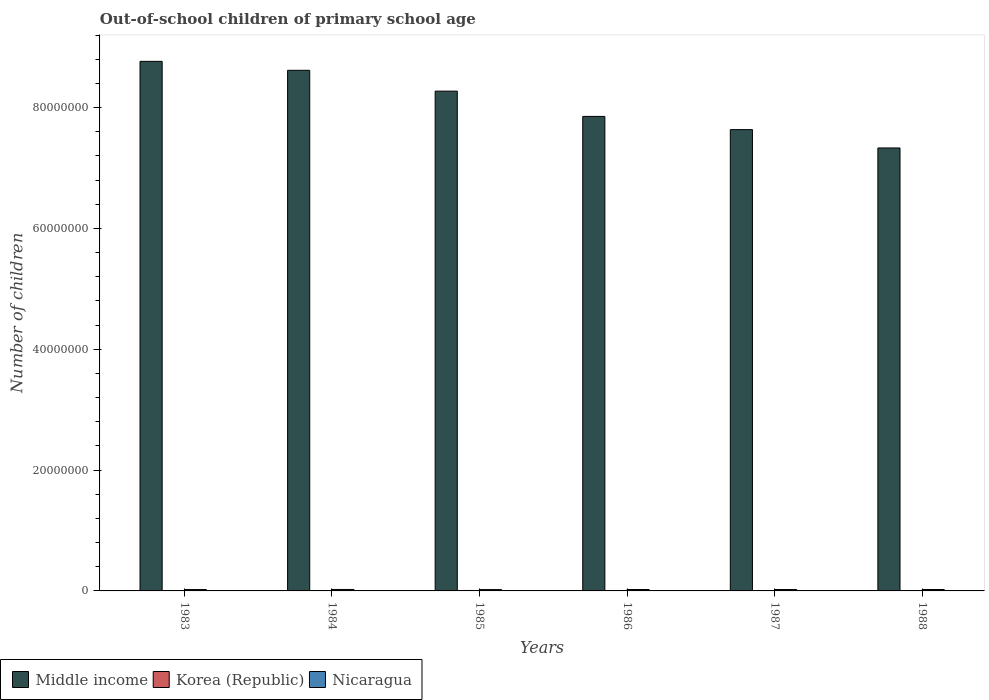How many different coloured bars are there?
Give a very brief answer. 3. How many groups of bars are there?
Offer a very short reply. 6. How many bars are there on the 2nd tick from the right?
Give a very brief answer. 3. What is the label of the 6th group of bars from the left?
Give a very brief answer. 1988. In how many cases, is the number of bars for a given year not equal to the number of legend labels?
Ensure brevity in your answer.  0. What is the number of out-of-school children in Korea (Republic) in 1987?
Give a very brief answer. 1.84e+04. Across all years, what is the maximum number of out-of-school children in Korea (Republic)?
Offer a terse response. 7.36e+04. Across all years, what is the minimum number of out-of-school children in Middle income?
Provide a short and direct response. 7.33e+07. In which year was the number of out-of-school children in Middle income minimum?
Ensure brevity in your answer.  1988. What is the total number of out-of-school children in Korea (Republic) in the graph?
Provide a succinct answer. 2.33e+05. What is the difference between the number of out-of-school children in Nicaragua in 1983 and that in 1984?
Make the answer very short. -1.61e+04. What is the difference between the number of out-of-school children in Korea (Republic) in 1985 and the number of out-of-school children in Nicaragua in 1984?
Your answer should be compact. -1.68e+05. What is the average number of out-of-school children in Nicaragua per year?
Ensure brevity in your answer.  2.31e+05. In the year 1983, what is the difference between the number of out-of-school children in Middle income and number of out-of-school children in Nicaragua?
Ensure brevity in your answer.  8.74e+07. What is the ratio of the number of out-of-school children in Middle income in 1983 to that in 1985?
Offer a very short reply. 1.06. What is the difference between the highest and the second highest number of out-of-school children in Middle income?
Your response must be concise. 1.48e+06. What is the difference between the highest and the lowest number of out-of-school children in Middle income?
Provide a short and direct response. 1.43e+07. In how many years, is the number of out-of-school children in Korea (Republic) greater than the average number of out-of-school children in Korea (Republic) taken over all years?
Keep it short and to the point. 3. What does the 3rd bar from the left in 1988 represents?
Ensure brevity in your answer.  Nicaragua. Is it the case that in every year, the sum of the number of out-of-school children in Korea (Republic) and number of out-of-school children in Nicaragua is greater than the number of out-of-school children in Middle income?
Make the answer very short. No. Are all the bars in the graph horizontal?
Keep it short and to the point. No. What is the difference between two consecutive major ticks on the Y-axis?
Provide a succinct answer. 2.00e+07. Does the graph contain any zero values?
Give a very brief answer. No. Does the graph contain grids?
Offer a very short reply. No. Where does the legend appear in the graph?
Ensure brevity in your answer.  Bottom left. How many legend labels are there?
Ensure brevity in your answer.  3. How are the legend labels stacked?
Make the answer very short. Horizontal. What is the title of the graph?
Offer a very short reply. Out-of-school children of primary school age. What is the label or title of the Y-axis?
Offer a terse response. Number of children. What is the Number of children in Middle income in 1983?
Offer a terse response. 8.77e+07. What is the Number of children of Korea (Republic) in 1983?
Ensure brevity in your answer.  9682. What is the Number of children of Nicaragua in 1983?
Provide a succinct answer. 2.25e+05. What is the Number of children in Middle income in 1984?
Keep it short and to the point. 8.62e+07. What is the Number of children in Korea (Republic) in 1984?
Keep it short and to the point. 4.08e+04. What is the Number of children of Nicaragua in 1984?
Your response must be concise. 2.41e+05. What is the Number of children in Middle income in 1985?
Ensure brevity in your answer.  8.27e+07. What is the Number of children of Korea (Republic) in 1985?
Provide a succinct answer. 7.36e+04. What is the Number of children in Nicaragua in 1985?
Give a very brief answer. 2.21e+05. What is the Number of children of Middle income in 1986?
Ensure brevity in your answer.  7.85e+07. What is the Number of children in Korea (Republic) in 1986?
Make the answer very short. 7.14e+04. What is the Number of children of Nicaragua in 1986?
Make the answer very short. 2.34e+05. What is the Number of children of Middle income in 1987?
Provide a succinct answer. 7.64e+07. What is the Number of children of Korea (Republic) in 1987?
Offer a terse response. 1.84e+04. What is the Number of children in Nicaragua in 1987?
Provide a succinct answer. 2.29e+05. What is the Number of children in Middle income in 1988?
Provide a short and direct response. 7.33e+07. What is the Number of children in Korea (Republic) in 1988?
Offer a very short reply. 1.92e+04. What is the Number of children of Nicaragua in 1988?
Provide a succinct answer. 2.34e+05. Across all years, what is the maximum Number of children of Middle income?
Offer a terse response. 8.77e+07. Across all years, what is the maximum Number of children in Korea (Republic)?
Make the answer very short. 7.36e+04. Across all years, what is the maximum Number of children of Nicaragua?
Keep it short and to the point. 2.41e+05. Across all years, what is the minimum Number of children in Middle income?
Your answer should be compact. 7.33e+07. Across all years, what is the minimum Number of children of Korea (Republic)?
Offer a very short reply. 9682. Across all years, what is the minimum Number of children of Nicaragua?
Ensure brevity in your answer.  2.21e+05. What is the total Number of children of Middle income in the graph?
Your answer should be very brief. 4.85e+08. What is the total Number of children in Korea (Republic) in the graph?
Your answer should be compact. 2.33e+05. What is the total Number of children in Nicaragua in the graph?
Your response must be concise. 1.39e+06. What is the difference between the Number of children in Middle income in 1983 and that in 1984?
Keep it short and to the point. 1.48e+06. What is the difference between the Number of children of Korea (Republic) in 1983 and that in 1984?
Make the answer very short. -3.11e+04. What is the difference between the Number of children of Nicaragua in 1983 and that in 1984?
Keep it short and to the point. -1.61e+04. What is the difference between the Number of children of Middle income in 1983 and that in 1985?
Provide a succinct answer. 4.93e+06. What is the difference between the Number of children in Korea (Republic) in 1983 and that in 1985?
Offer a very short reply. -6.39e+04. What is the difference between the Number of children of Nicaragua in 1983 and that in 1985?
Your response must be concise. 3647. What is the difference between the Number of children in Middle income in 1983 and that in 1986?
Your answer should be very brief. 9.11e+06. What is the difference between the Number of children in Korea (Republic) in 1983 and that in 1986?
Make the answer very short. -6.17e+04. What is the difference between the Number of children in Nicaragua in 1983 and that in 1986?
Provide a succinct answer. -9017. What is the difference between the Number of children in Middle income in 1983 and that in 1987?
Offer a very short reply. 1.13e+07. What is the difference between the Number of children in Korea (Republic) in 1983 and that in 1987?
Keep it short and to the point. -8751. What is the difference between the Number of children of Nicaragua in 1983 and that in 1987?
Provide a succinct answer. -4156. What is the difference between the Number of children of Middle income in 1983 and that in 1988?
Your response must be concise. 1.43e+07. What is the difference between the Number of children of Korea (Republic) in 1983 and that in 1988?
Your answer should be compact. -9494. What is the difference between the Number of children in Nicaragua in 1983 and that in 1988?
Keep it short and to the point. -8803. What is the difference between the Number of children in Middle income in 1984 and that in 1985?
Make the answer very short. 3.45e+06. What is the difference between the Number of children of Korea (Republic) in 1984 and that in 1985?
Ensure brevity in your answer.  -3.28e+04. What is the difference between the Number of children in Nicaragua in 1984 and that in 1985?
Make the answer very short. 1.98e+04. What is the difference between the Number of children of Middle income in 1984 and that in 1986?
Provide a succinct answer. 7.63e+06. What is the difference between the Number of children of Korea (Republic) in 1984 and that in 1986?
Offer a terse response. -3.06e+04. What is the difference between the Number of children of Nicaragua in 1984 and that in 1986?
Offer a very short reply. 7090. What is the difference between the Number of children in Middle income in 1984 and that in 1987?
Offer a very short reply. 9.82e+06. What is the difference between the Number of children in Korea (Republic) in 1984 and that in 1987?
Your answer should be compact. 2.23e+04. What is the difference between the Number of children in Nicaragua in 1984 and that in 1987?
Provide a short and direct response. 1.20e+04. What is the difference between the Number of children of Middle income in 1984 and that in 1988?
Offer a very short reply. 1.29e+07. What is the difference between the Number of children in Korea (Republic) in 1984 and that in 1988?
Your answer should be compact. 2.16e+04. What is the difference between the Number of children in Nicaragua in 1984 and that in 1988?
Provide a short and direct response. 7304. What is the difference between the Number of children of Middle income in 1985 and that in 1986?
Your answer should be very brief. 4.19e+06. What is the difference between the Number of children of Korea (Republic) in 1985 and that in 1986?
Your response must be concise. 2213. What is the difference between the Number of children in Nicaragua in 1985 and that in 1986?
Ensure brevity in your answer.  -1.27e+04. What is the difference between the Number of children of Middle income in 1985 and that in 1987?
Provide a succinct answer. 6.37e+06. What is the difference between the Number of children in Korea (Republic) in 1985 and that in 1987?
Offer a very short reply. 5.52e+04. What is the difference between the Number of children of Nicaragua in 1985 and that in 1987?
Offer a very short reply. -7803. What is the difference between the Number of children in Middle income in 1985 and that in 1988?
Your answer should be very brief. 9.41e+06. What is the difference between the Number of children of Korea (Republic) in 1985 and that in 1988?
Your answer should be compact. 5.44e+04. What is the difference between the Number of children in Nicaragua in 1985 and that in 1988?
Provide a succinct answer. -1.24e+04. What is the difference between the Number of children of Middle income in 1986 and that in 1987?
Your answer should be compact. 2.18e+06. What is the difference between the Number of children of Korea (Republic) in 1986 and that in 1987?
Provide a succinct answer. 5.29e+04. What is the difference between the Number of children of Nicaragua in 1986 and that in 1987?
Your answer should be very brief. 4861. What is the difference between the Number of children in Middle income in 1986 and that in 1988?
Make the answer very short. 5.22e+06. What is the difference between the Number of children in Korea (Republic) in 1986 and that in 1988?
Your answer should be compact. 5.22e+04. What is the difference between the Number of children of Nicaragua in 1986 and that in 1988?
Offer a terse response. 214. What is the difference between the Number of children in Middle income in 1987 and that in 1988?
Offer a very short reply. 3.04e+06. What is the difference between the Number of children of Korea (Republic) in 1987 and that in 1988?
Provide a short and direct response. -743. What is the difference between the Number of children of Nicaragua in 1987 and that in 1988?
Your response must be concise. -4647. What is the difference between the Number of children of Middle income in 1983 and the Number of children of Korea (Republic) in 1984?
Offer a terse response. 8.76e+07. What is the difference between the Number of children in Middle income in 1983 and the Number of children in Nicaragua in 1984?
Keep it short and to the point. 8.74e+07. What is the difference between the Number of children of Korea (Republic) in 1983 and the Number of children of Nicaragua in 1984?
Make the answer very short. -2.32e+05. What is the difference between the Number of children in Middle income in 1983 and the Number of children in Korea (Republic) in 1985?
Offer a terse response. 8.76e+07. What is the difference between the Number of children in Middle income in 1983 and the Number of children in Nicaragua in 1985?
Your response must be concise. 8.74e+07. What is the difference between the Number of children in Korea (Republic) in 1983 and the Number of children in Nicaragua in 1985?
Keep it short and to the point. -2.12e+05. What is the difference between the Number of children of Middle income in 1983 and the Number of children of Korea (Republic) in 1986?
Give a very brief answer. 8.76e+07. What is the difference between the Number of children of Middle income in 1983 and the Number of children of Nicaragua in 1986?
Your answer should be very brief. 8.74e+07. What is the difference between the Number of children in Korea (Republic) in 1983 and the Number of children in Nicaragua in 1986?
Your answer should be compact. -2.24e+05. What is the difference between the Number of children in Middle income in 1983 and the Number of children in Korea (Republic) in 1987?
Your answer should be very brief. 8.76e+07. What is the difference between the Number of children in Middle income in 1983 and the Number of children in Nicaragua in 1987?
Offer a terse response. 8.74e+07. What is the difference between the Number of children of Korea (Republic) in 1983 and the Number of children of Nicaragua in 1987?
Give a very brief answer. -2.20e+05. What is the difference between the Number of children of Middle income in 1983 and the Number of children of Korea (Republic) in 1988?
Make the answer very short. 8.76e+07. What is the difference between the Number of children of Middle income in 1983 and the Number of children of Nicaragua in 1988?
Make the answer very short. 8.74e+07. What is the difference between the Number of children of Korea (Republic) in 1983 and the Number of children of Nicaragua in 1988?
Give a very brief answer. -2.24e+05. What is the difference between the Number of children in Middle income in 1984 and the Number of children in Korea (Republic) in 1985?
Your answer should be very brief. 8.61e+07. What is the difference between the Number of children of Middle income in 1984 and the Number of children of Nicaragua in 1985?
Offer a terse response. 8.60e+07. What is the difference between the Number of children in Korea (Republic) in 1984 and the Number of children in Nicaragua in 1985?
Make the answer very short. -1.81e+05. What is the difference between the Number of children in Middle income in 1984 and the Number of children in Korea (Republic) in 1986?
Provide a succinct answer. 8.61e+07. What is the difference between the Number of children in Middle income in 1984 and the Number of children in Nicaragua in 1986?
Your response must be concise. 8.59e+07. What is the difference between the Number of children of Korea (Republic) in 1984 and the Number of children of Nicaragua in 1986?
Make the answer very short. -1.93e+05. What is the difference between the Number of children in Middle income in 1984 and the Number of children in Korea (Republic) in 1987?
Ensure brevity in your answer.  8.62e+07. What is the difference between the Number of children of Middle income in 1984 and the Number of children of Nicaragua in 1987?
Your answer should be very brief. 8.59e+07. What is the difference between the Number of children of Korea (Republic) in 1984 and the Number of children of Nicaragua in 1987?
Your answer should be compact. -1.89e+05. What is the difference between the Number of children of Middle income in 1984 and the Number of children of Korea (Republic) in 1988?
Provide a succinct answer. 8.62e+07. What is the difference between the Number of children in Middle income in 1984 and the Number of children in Nicaragua in 1988?
Give a very brief answer. 8.59e+07. What is the difference between the Number of children in Korea (Republic) in 1984 and the Number of children in Nicaragua in 1988?
Keep it short and to the point. -1.93e+05. What is the difference between the Number of children in Middle income in 1985 and the Number of children in Korea (Republic) in 1986?
Offer a very short reply. 8.27e+07. What is the difference between the Number of children in Middle income in 1985 and the Number of children in Nicaragua in 1986?
Provide a short and direct response. 8.25e+07. What is the difference between the Number of children in Korea (Republic) in 1985 and the Number of children in Nicaragua in 1986?
Keep it short and to the point. -1.61e+05. What is the difference between the Number of children of Middle income in 1985 and the Number of children of Korea (Republic) in 1987?
Your response must be concise. 8.27e+07. What is the difference between the Number of children of Middle income in 1985 and the Number of children of Nicaragua in 1987?
Your answer should be compact. 8.25e+07. What is the difference between the Number of children of Korea (Republic) in 1985 and the Number of children of Nicaragua in 1987?
Ensure brevity in your answer.  -1.56e+05. What is the difference between the Number of children in Middle income in 1985 and the Number of children in Korea (Republic) in 1988?
Your answer should be compact. 8.27e+07. What is the difference between the Number of children in Middle income in 1985 and the Number of children in Nicaragua in 1988?
Make the answer very short. 8.25e+07. What is the difference between the Number of children of Korea (Republic) in 1985 and the Number of children of Nicaragua in 1988?
Give a very brief answer. -1.60e+05. What is the difference between the Number of children in Middle income in 1986 and the Number of children in Korea (Republic) in 1987?
Give a very brief answer. 7.85e+07. What is the difference between the Number of children of Middle income in 1986 and the Number of children of Nicaragua in 1987?
Make the answer very short. 7.83e+07. What is the difference between the Number of children in Korea (Republic) in 1986 and the Number of children in Nicaragua in 1987?
Give a very brief answer. -1.58e+05. What is the difference between the Number of children in Middle income in 1986 and the Number of children in Korea (Republic) in 1988?
Give a very brief answer. 7.85e+07. What is the difference between the Number of children in Middle income in 1986 and the Number of children in Nicaragua in 1988?
Your answer should be very brief. 7.83e+07. What is the difference between the Number of children in Korea (Republic) in 1986 and the Number of children in Nicaragua in 1988?
Your answer should be compact. -1.63e+05. What is the difference between the Number of children in Middle income in 1987 and the Number of children in Korea (Republic) in 1988?
Keep it short and to the point. 7.63e+07. What is the difference between the Number of children of Middle income in 1987 and the Number of children of Nicaragua in 1988?
Provide a succinct answer. 7.61e+07. What is the difference between the Number of children in Korea (Republic) in 1987 and the Number of children in Nicaragua in 1988?
Your response must be concise. -2.16e+05. What is the average Number of children of Middle income per year?
Keep it short and to the point. 8.08e+07. What is the average Number of children in Korea (Republic) per year?
Provide a succinct answer. 3.88e+04. What is the average Number of children of Nicaragua per year?
Your answer should be very brief. 2.31e+05. In the year 1983, what is the difference between the Number of children in Middle income and Number of children in Korea (Republic)?
Ensure brevity in your answer.  8.76e+07. In the year 1983, what is the difference between the Number of children of Middle income and Number of children of Nicaragua?
Your answer should be compact. 8.74e+07. In the year 1983, what is the difference between the Number of children of Korea (Republic) and Number of children of Nicaragua?
Offer a very short reply. -2.15e+05. In the year 1984, what is the difference between the Number of children of Middle income and Number of children of Korea (Republic)?
Keep it short and to the point. 8.61e+07. In the year 1984, what is the difference between the Number of children of Middle income and Number of children of Nicaragua?
Offer a very short reply. 8.59e+07. In the year 1984, what is the difference between the Number of children in Korea (Republic) and Number of children in Nicaragua?
Offer a very short reply. -2.00e+05. In the year 1985, what is the difference between the Number of children in Middle income and Number of children in Korea (Republic)?
Keep it short and to the point. 8.27e+07. In the year 1985, what is the difference between the Number of children of Middle income and Number of children of Nicaragua?
Provide a succinct answer. 8.25e+07. In the year 1985, what is the difference between the Number of children of Korea (Republic) and Number of children of Nicaragua?
Your answer should be very brief. -1.48e+05. In the year 1986, what is the difference between the Number of children in Middle income and Number of children in Korea (Republic)?
Offer a very short reply. 7.85e+07. In the year 1986, what is the difference between the Number of children in Middle income and Number of children in Nicaragua?
Provide a succinct answer. 7.83e+07. In the year 1986, what is the difference between the Number of children of Korea (Republic) and Number of children of Nicaragua?
Offer a very short reply. -1.63e+05. In the year 1987, what is the difference between the Number of children in Middle income and Number of children in Korea (Republic)?
Offer a terse response. 7.63e+07. In the year 1987, what is the difference between the Number of children in Middle income and Number of children in Nicaragua?
Keep it short and to the point. 7.61e+07. In the year 1987, what is the difference between the Number of children in Korea (Republic) and Number of children in Nicaragua?
Ensure brevity in your answer.  -2.11e+05. In the year 1988, what is the difference between the Number of children of Middle income and Number of children of Korea (Republic)?
Make the answer very short. 7.33e+07. In the year 1988, what is the difference between the Number of children in Middle income and Number of children in Nicaragua?
Keep it short and to the point. 7.31e+07. In the year 1988, what is the difference between the Number of children in Korea (Republic) and Number of children in Nicaragua?
Your answer should be compact. -2.15e+05. What is the ratio of the Number of children in Middle income in 1983 to that in 1984?
Offer a terse response. 1.02. What is the ratio of the Number of children of Korea (Republic) in 1983 to that in 1984?
Offer a terse response. 0.24. What is the ratio of the Number of children of Nicaragua in 1983 to that in 1984?
Ensure brevity in your answer.  0.93. What is the ratio of the Number of children of Middle income in 1983 to that in 1985?
Keep it short and to the point. 1.06. What is the ratio of the Number of children of Korea (Republic) in 1983 to that in 1985?
Your response must be concise. 0.13. What is the ratio of the Number of children in Nicaragua in 1983 to that in 1985?
Provide a short and direct response. 1.02. What is the ratio of the Number of children in Middle income in 1983 to that in 1986?
Your answer should be compact. 1.12. What is the ratio of the Number of children of Korea (Republic) in 1983 to that in 1986?
Provide a succinct answer. 0.14. What is the ratio of the Number of children of Nicaragua in 1983 to that in 1986?
Provide a short and direct response. 0.96. What is the ratio of the Number of children of Middle income in 1983 to that in 1987?
Your answer should be compact. 1.15. What is the ratio of the Number of children of Korea (Republic) in 1983 to that in 1987?
Provide a short and direct response. 0.53. What is the ratio of the Number of children of Nicaragua in 1983 to that in 1987?
Your response must be concise. 0.98. What is the ratio of the Number of children in Middle income in 1983 to that in 1988?
Your answer should be very brief. 1.2. What is the ratio of the Number of children in Korea (Republic) in 1983 to that in 1988?
Provide a succinct answer. 0.5. What is the ratio of the Number of children of Nicaragua in 1983 to that in 1988?
Your answer should be compact. 0.96. What is the ratio of the Number of children of Middle income in 1984 to that in 1985?
Offer a very short reply. 1.04. What is the ratio of the Number of children in Korea (Republic) in 1984 to that in 1985?
Give a very brief answer. 0.55. What is the ratio of the Number of children in Nicaragua in 1984 to that in 1985?
Your answer should be compact. 1.09. What is the ratio of the Number of children in Middle income in 1984 to that in 1986?
Your response must be concise. 1.1. What is the ratio of the Number of children in Korea (Republic) in 1984 to that in 1986?
Make the answer very short. 0.57. What is the ratio of the Number of children in Nicaragua in 1984 to that in 1986?
Your response must be concise. 1.03. What is the ratio of the Number of children in Middle income in 1984 to that in 1987?
Offer a terse response. 1.13. What is the ratio of the Number of children of Korea (Republic) in 1984 to that in 1987?
Make the answer very short. 2.21. What is the ratio of the Number of children in Nicaragua in 1984 to that in 1987?
Make the answer very short. 1.05. What is the ratio of the Number of children of Middle income in 1984 to that in 1988?
Keep it short and to the point. 1.18. What is the ratio of the Number of children in Korea (Republic) in 1984 to that in 1988?
Provide a short and direct response. 2.13. What is the ratio of the Number of children of Nicaragua in 1984 to that in 1988?
Give a very brief answer. 1.03. What is the ratio of the Number of children of Middle income in 1985 to that in 1986?
Your response must be concise. 1.05. What is the ratio of the Number of children in Korea (Republic) in 1985 to that in 1986?
Provide a short and direct response. 1.03. What is the ratio of the Number of children of Nicaragua in 1985 to that in 1986?
Make the answer very short. 0.95. What is the ratio of the Number of children of Middle income in 1985 to that in 1987?
Your response must be concise. 1.08. What is the ratio of the Number of children in Korea (Republic) in 1985 to that in 1987?
Keep it short and to the point. 3.99. What is the ratio of the Number of children of Middle income in 1985 to that in 1988?
Offer a terse response. 1.13. What is the ratio of the Number of children in Korea (Republic) in 1985 to that in 1988?
Make the answer very short. 3.84. What is the ratio of the Number of children in Nicaragua in 1985 to that in 1988?
Your answer should be very brief. 0.95. What is the ratio of the Number of children of Middle income in 1986 to that in 1987?
Your response must be concise. 1.03. What is the ratio of the Number of children in Korea (Republic) in 1986 to that in 1987?
Offer a very short reply. 3.87. What is the ratio of the Number of children in Nicaragua in 1986 to that in 1987?
Offer a terse response. 1.02. What is the ratio of the Number of children of Middle income in 1986 to that in 1988?
Provide a succinct answer. 1.07. What is the ratio of the Number of children of Korea (Republic) in 1986 to that in 1988?
Keep it short and to the point. 3.72. What is the ratio of the Number of children in Nicaragua in 1986 to that in 1988?
Keep it short and to the point. 1. What is the ratio of the Number of children in Middle income in 1987 to that in 1988?
Your answer should be very brief. 1.04. What is the ratio of the Number of children of Korea (Republic) in 1987 to that in 1988?
Offer a terse response. 0.96. What is the ratio of the Number of children of Nicaragua in 1987 to that in 1988?
Keep it short and to the point. 0.98. What is the difference between the highest and the second highest Number of children in Middle income?
Provide a short and direct response. 1.48e+06. What is the difference between the highest and the second highest Number of children in Korea (Republic)?
Ensure brevity in your answer.  2213. What is the difference between the highest and the second highest Number of children in Nicaragua?
Provide a short and direct response. 7090. What is the difference between the highest and the lowest Number of children of Middle income?
Keep it short and to the point. 1.43e+07. What is the difference between the highest and the lowest Number of children in Korea (Republic)?
Your answer should be compact. 6.39e+04. What is the difference between the highest and the lowest Number of children of Nicaragua?
Give a very brief answer. 1.98e+04. 